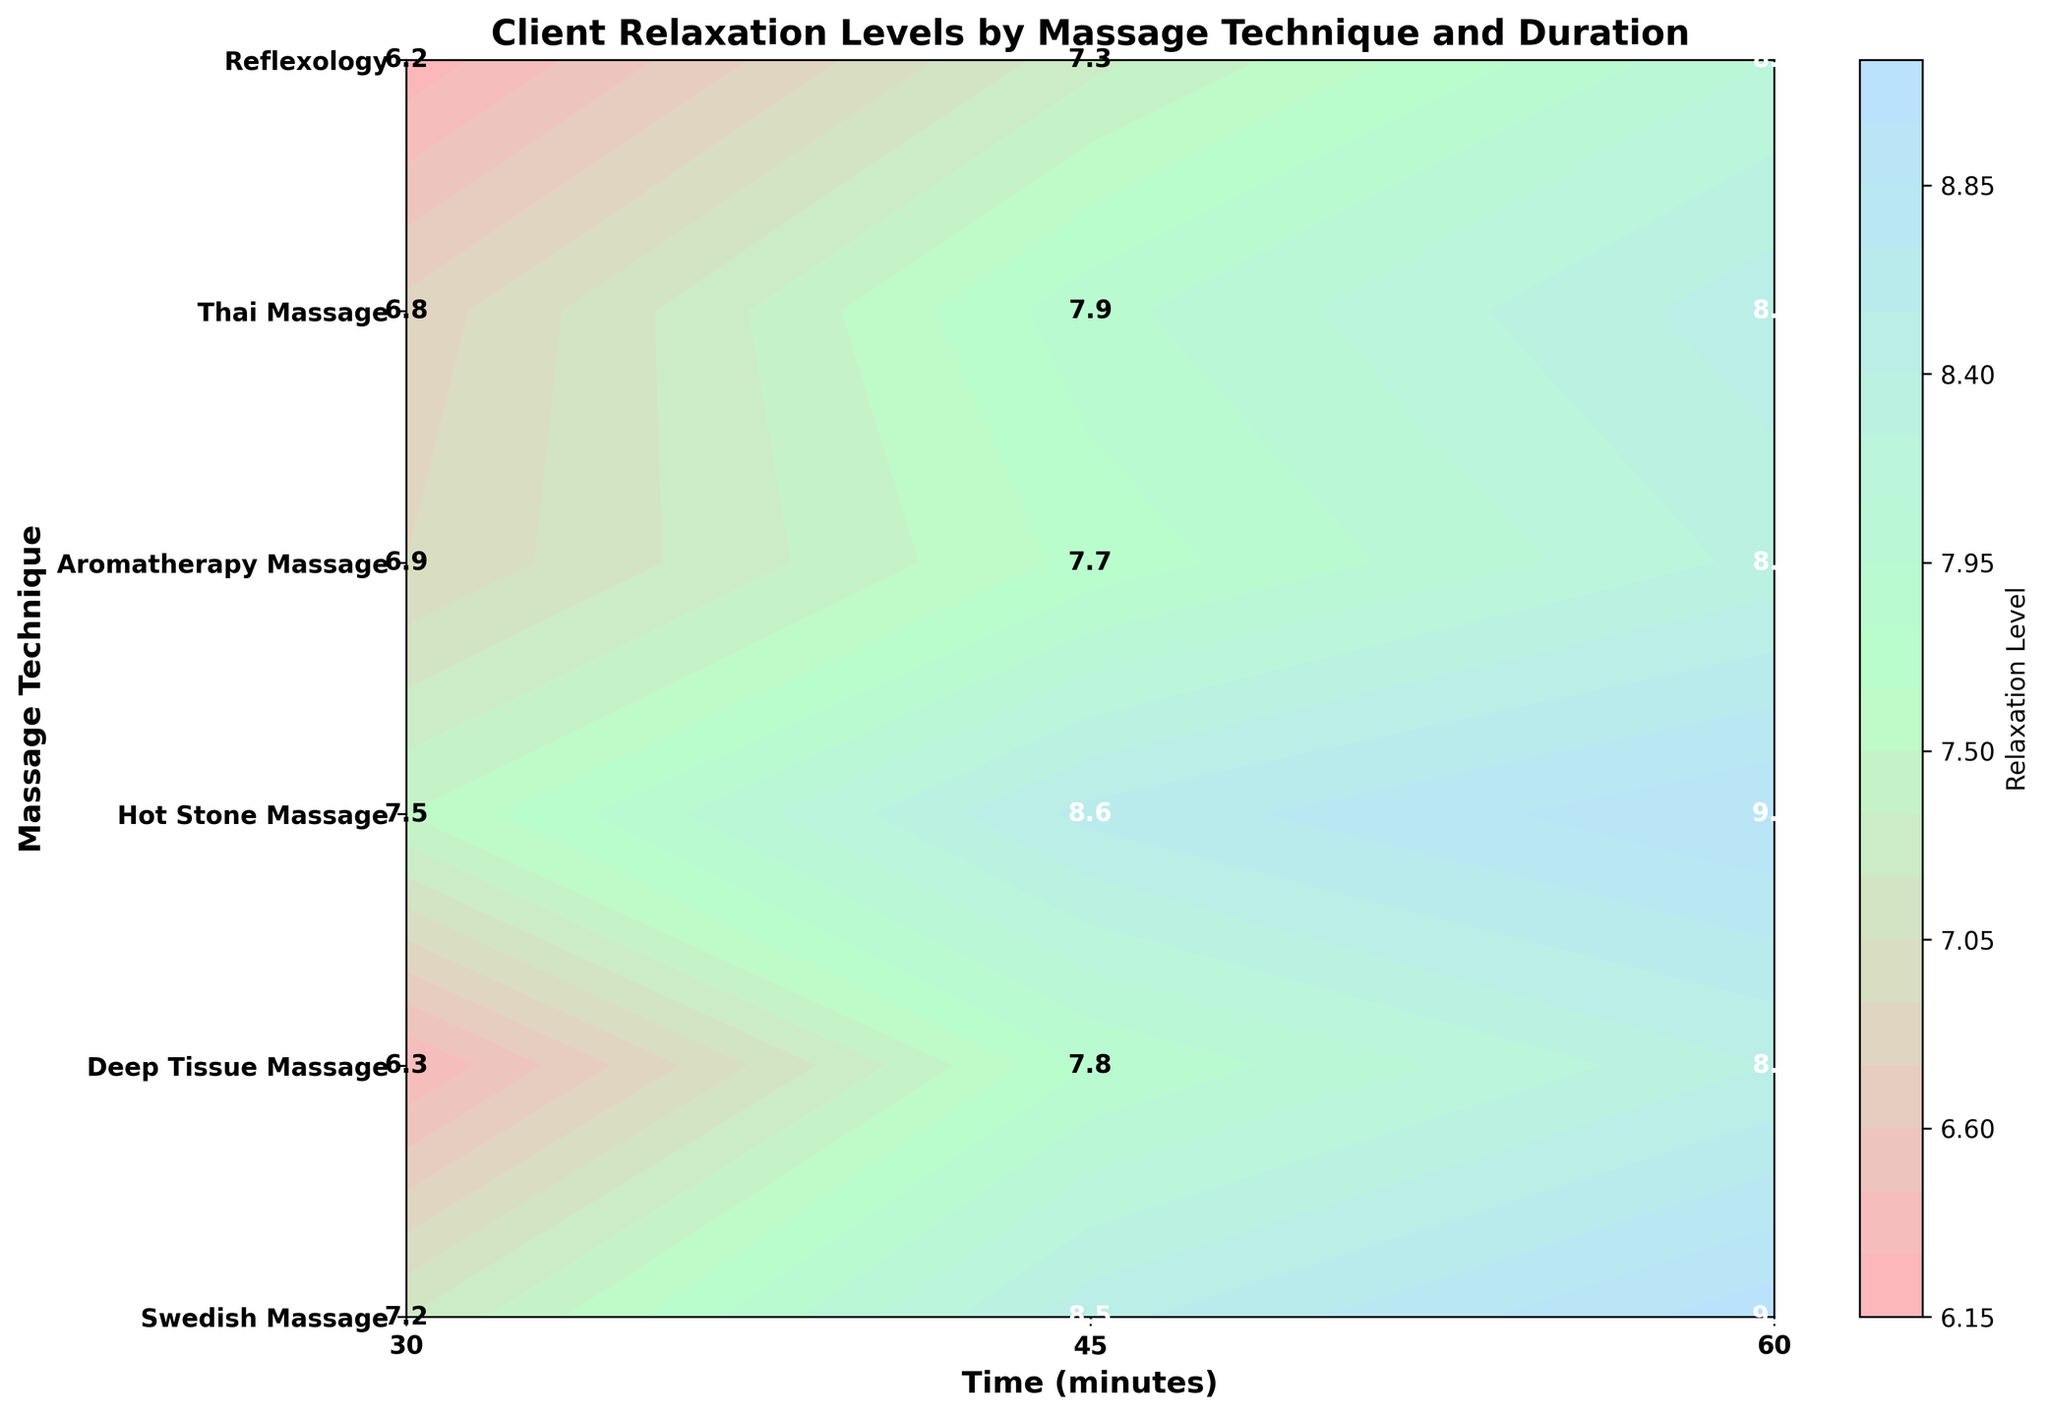What's the title of the figure? The title is displayed at the top of the figure. It provides an overview of what the figure is about.
Answer: Client Relaxation Levels by Massage Technique and Duration What is the relaxation level for Hot Stone Massage at 60 minutes? Find the label where "Hot Stone Massage" intersects with "60 minutes" on the x-axis and read the relaxation level from the plot or the text label inside the contour.
Answer: 9.0 Which massage technique results in the highest relaxation level at 45 minutes? Look at all the massage techniques listed on the y-axis and compare their relaxation levels at 45 minutes from the x-axis. Identify the highest value.
Answer: Hot Stone Massage What is the difference in relaxation level between Swedish Massage and Aromatherapy Massage at 30 minutes? Locate the relaxation levels for Swedish Massage and Aromatherapy Massage at 30 minutes on the plot and subtract the Aromatherapy value from the Swedish value: 7.2 – 6.9.
Answer: 0.3 Which massage technique had the lowest relaxation level at 30 minutes? Among the values given for 30 minutes across all massage techniques, identify the lowest value. Refer to the corresponding technique on the y-axis.
Answer: Reflexology Comparing Deep Tissue Massage and Thai Massage at 45 minutes, which one has a higher relaxation level and by how much? Identify the relaxation levels for both techniques at 45 minutes from the plot and subtract the lower value from the higher value: 7.9 – 7.8.
Answer: Thai Massage, 0.1 What is the average relaxation level across all techniques at 60 minutes? Add up the relaxation levels for all techniques at 60 minutes from the plot and divide by the number of techniques: (9.1 + 8.4 + 9.0 + 8.3 + 8.5 + 8.1) / 6.
Answer: 8.57 Does reflexology ever provide a relaxation level above 8 at any duration? Check the relaxation levels provided for Reflexology at all durations (30, 45, 60 minutes) and see if any value is greater than 8.
Answer: Yes What is the average relaxation level for Swedish Massage across all durations? Add the relaxation levels of Swedish Massage at 30, 45, and 60 minutes and divide by 3: (7.2 + 8.5 + 9.1) / 3.
Answer: 8.27 